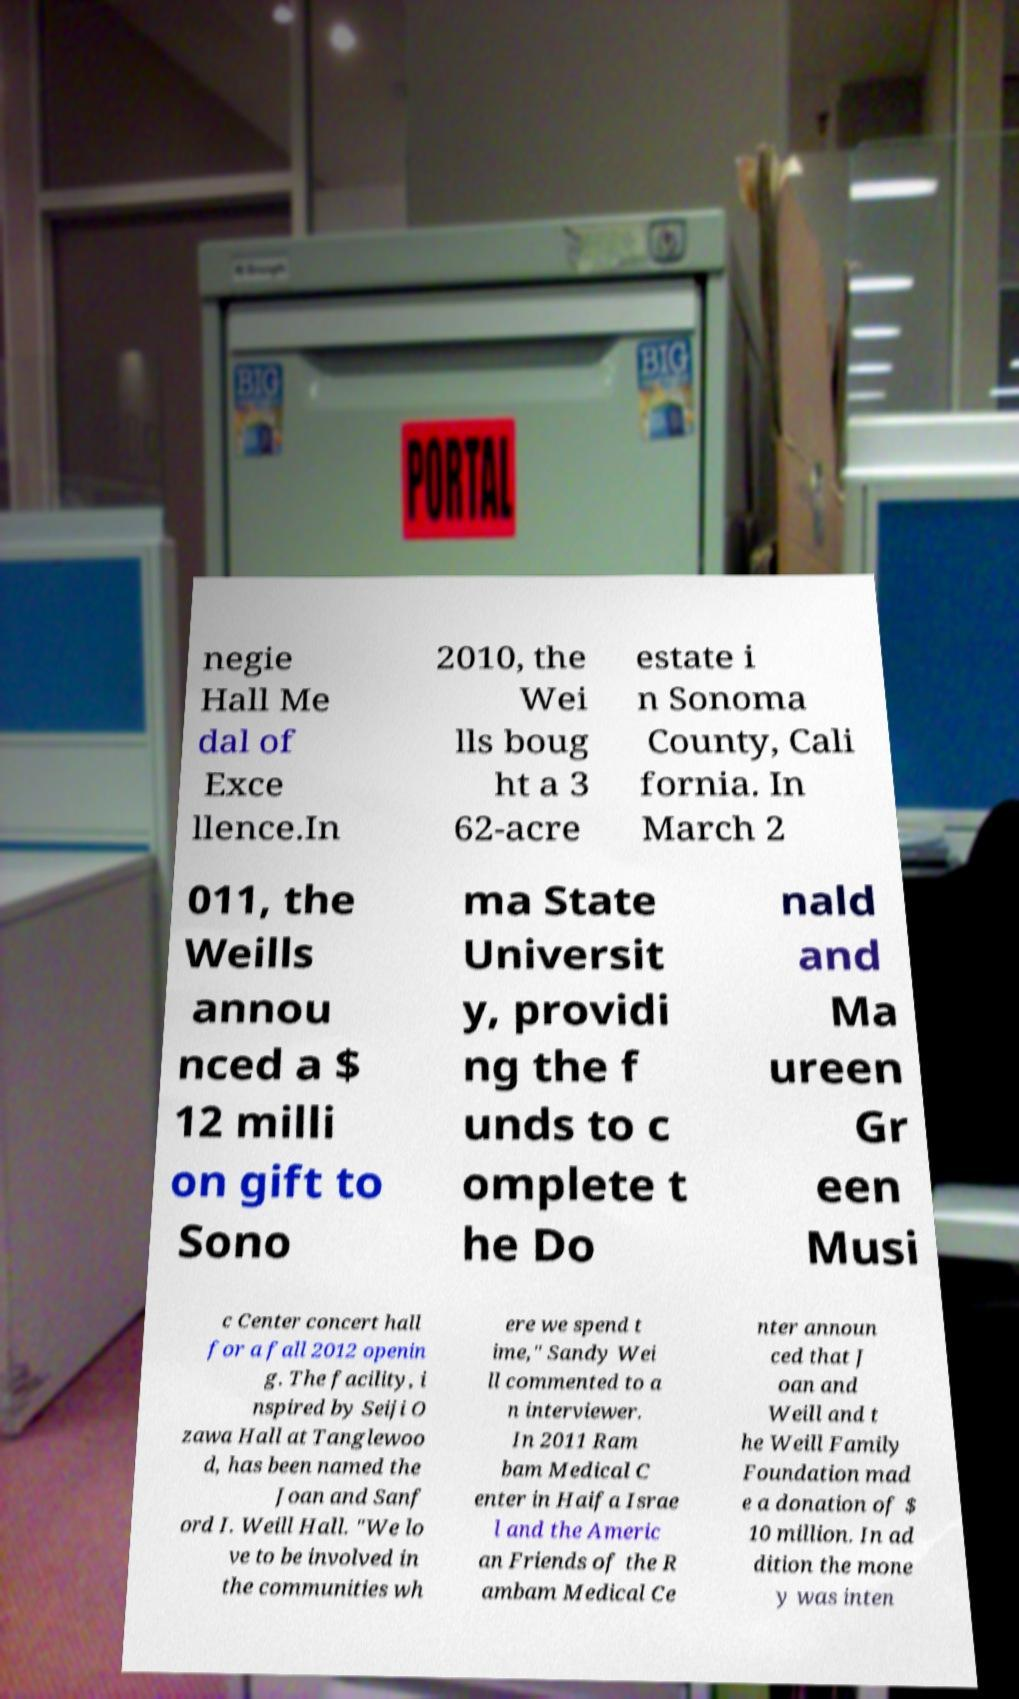For documentation purposes, I need the text within this image transcribed. Could you provide that? negie Hall Me dal of Exce llence.In 2010, the Wei lls boug ht a 3 62-acre estate i n Sonoma County, Cali fornia. In March 2 011, the Weills annou nced a $ 12 milli on gift to Sono ma State Universit y, providi ng the f unds to c omplete t he Do nald and Ma ureen Gr een Musi c Center concert hall for a fall 2012 openin g. The facility, i nspired by Seiji O zawa Hall at Tanglewoo d, has been named the Joan and Sanf ord I. Weill Hall. "We lo ve to be involved in the communities wh ere we spend t ime," Sandy Wei ll commented to a n interviewer. In 2011 Ram bam Medical C enter in Haifa Israe l and the Americ an Friends of the R ambam Medical Ce nter announ ced that J oan and Weill and t he Weill Family Foundation mad e a donation of $ 10 million. In ad dition the mone y was inten 